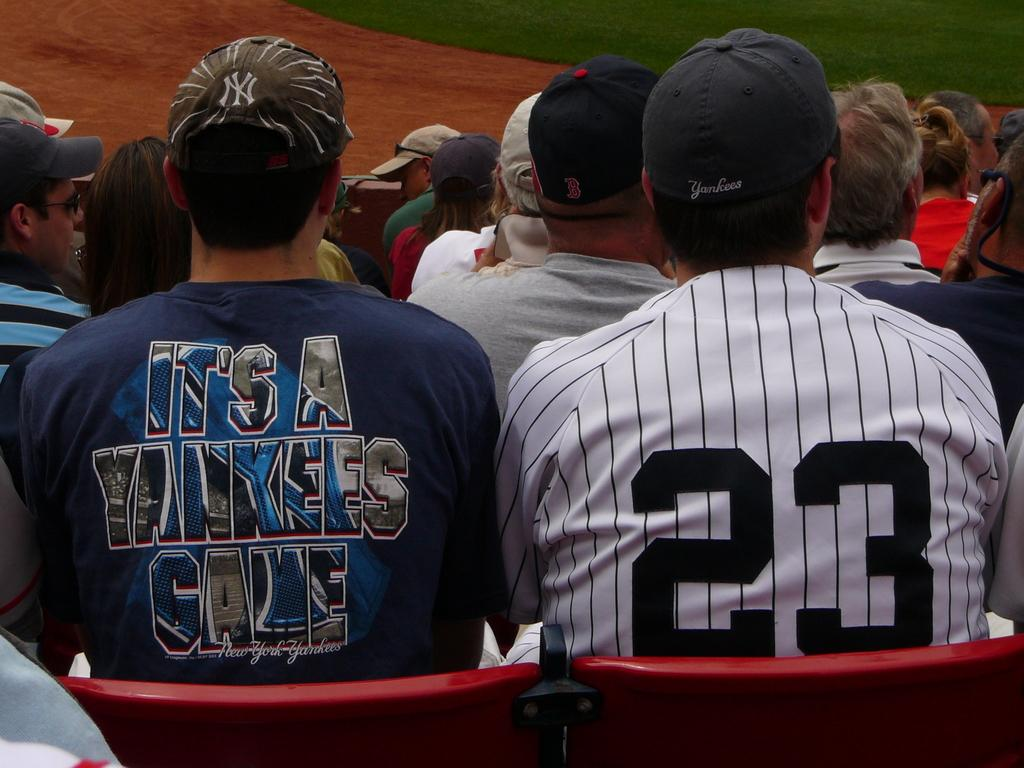<image>
Describe the image concisely. A man wearing a shirt that says, "It's a Yankees Game", sits in a stadium chair next to another man with the number 23 on his shirt. 